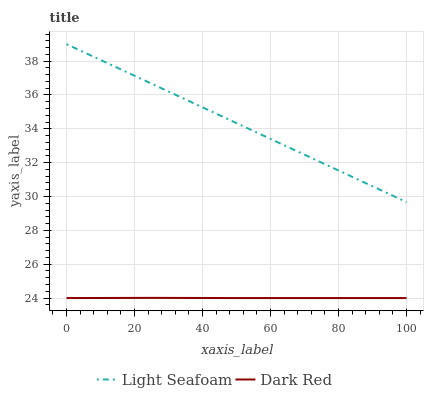Does Light Seafoam have the minimum area under the curve?
Answer yes or no. No. Is Light Seafoam the roughest?
Answer yes or no. No. Does Light Seafoam have the lowest value?
Answer yes or no. No. Is Dark Red less than Light Seafoam?
Answer yes or no. Yes. Is Light Seafoam greater than Dark Red?
Answer yes or no. Yes. Does Dark Red intersect Light Seafoam?
Answer yes or no. No. 